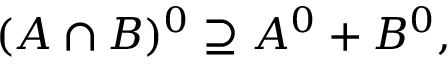Convert formula to latex. <formula><loc_0><loc_0><loc_500><loc_500>( A \cap B ) ^ { 0 } \supseteq A ^ { 0 } + B ^ { 0 } ,</formula> 